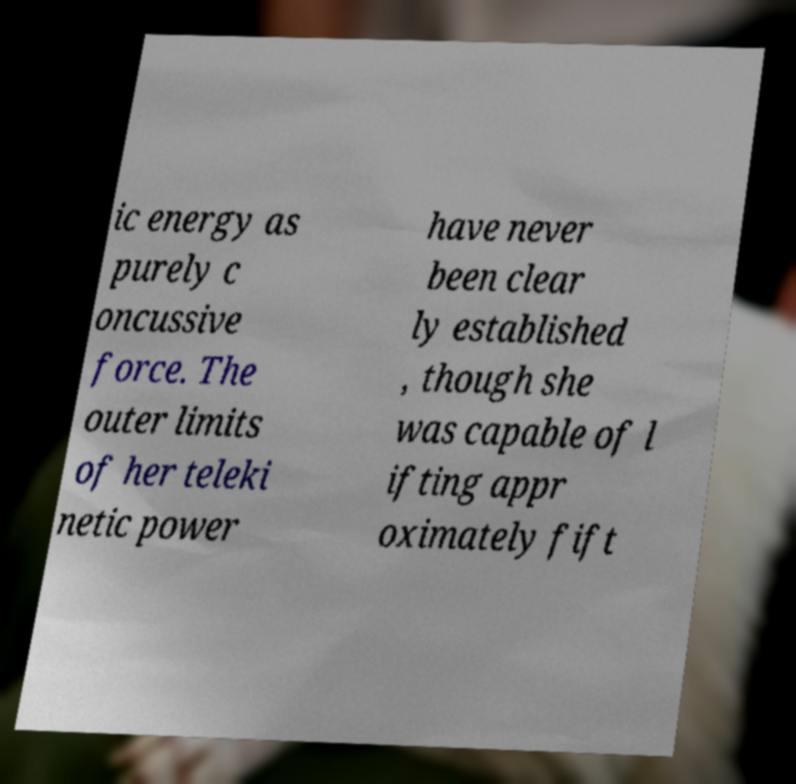Could you extract and type out the text from this image? ic energy as purely c oncussive force. The outer limits of her teleki netic power have never been clear ly established , though she was capable of l ifting appr oximately fift 